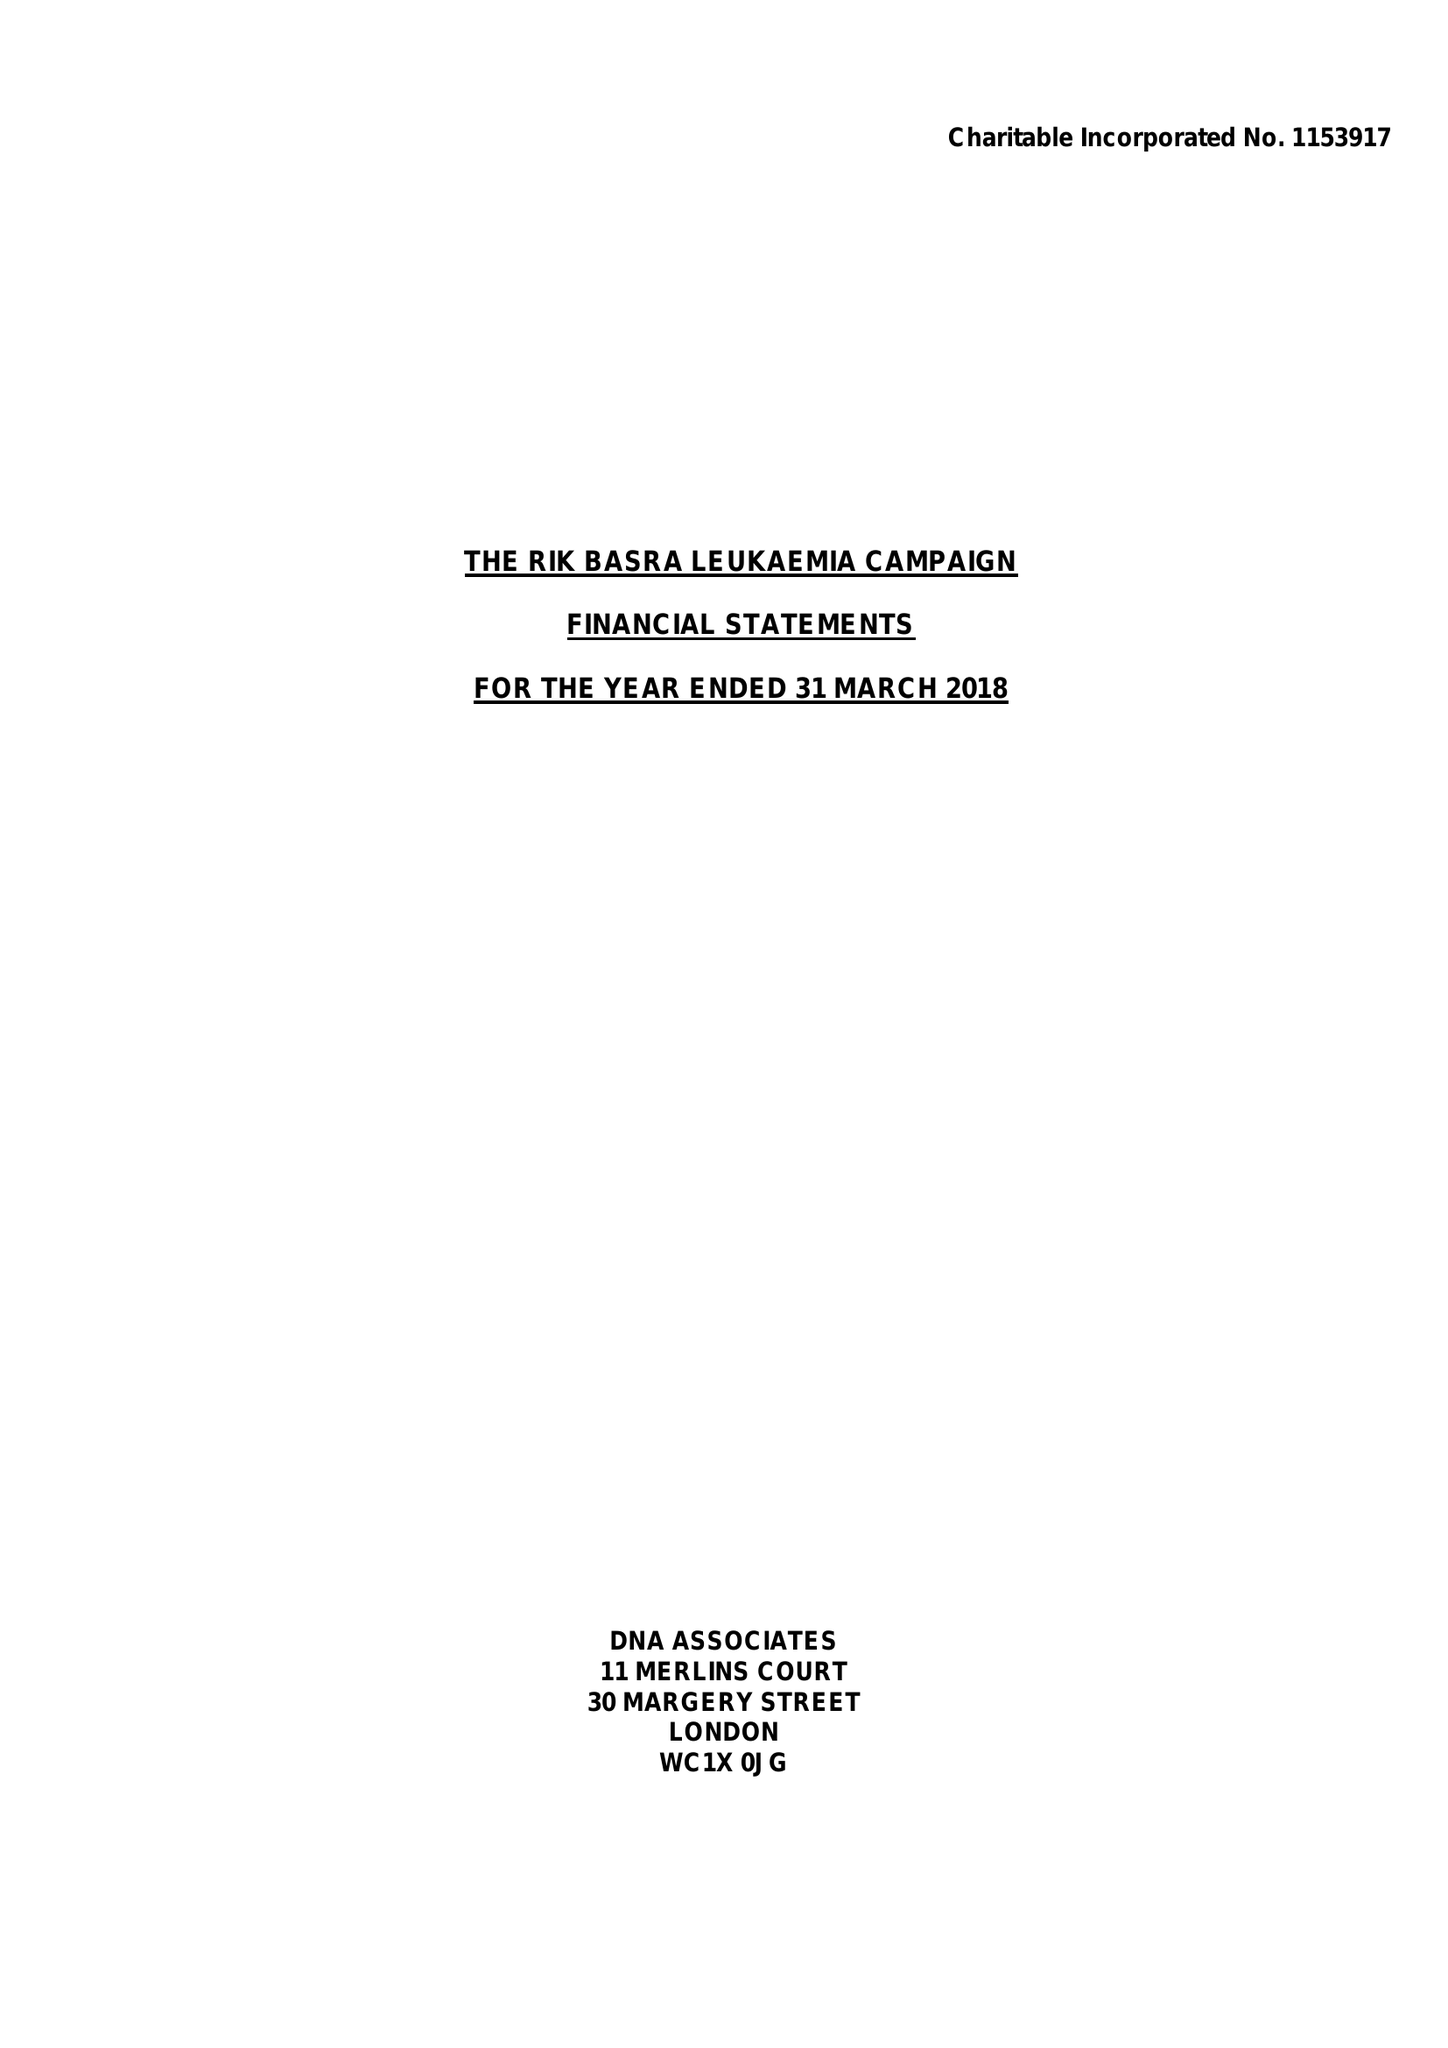What is the value for the address__postcode?
Answer the question using a single word or phrase. LE8 0JS 